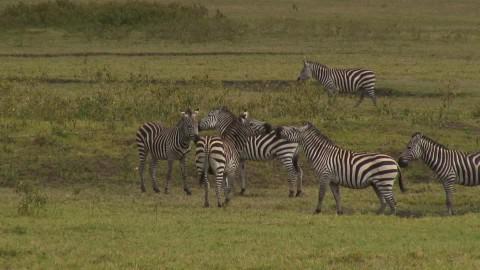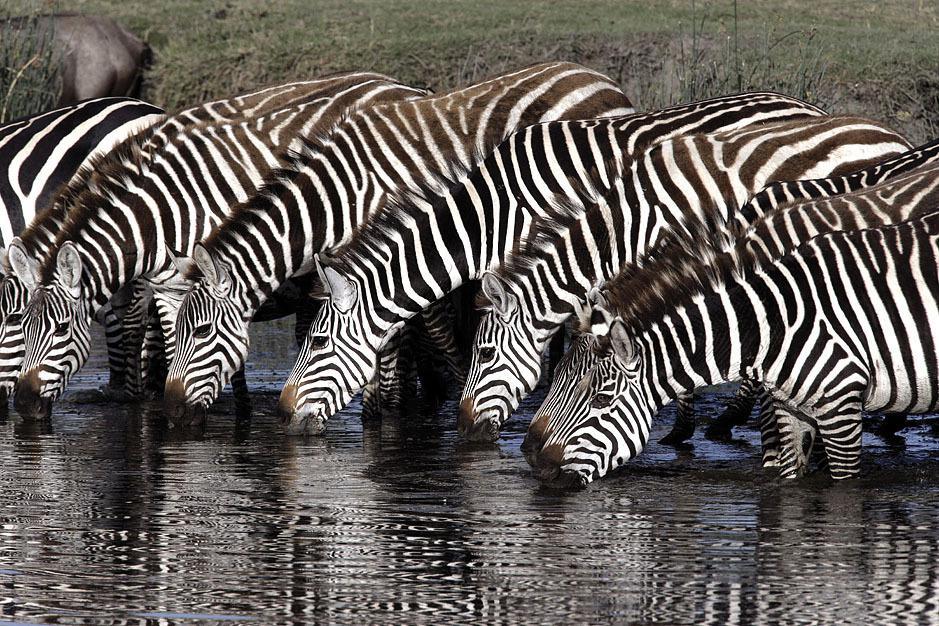The first image is the image on the left, the second image is the image on the right. Considering the images on both sides, is "One image shows leftward-facing zebras lined up with bent heads drinking from water they are standing in." valid? Answer yes or no. Yes. The first image is the image on the left, the second image is the image on the right. For the images displayed, is the sentence "there are zebras standing in a row drinking water" factually correct? Answer yes or no. Yes. 